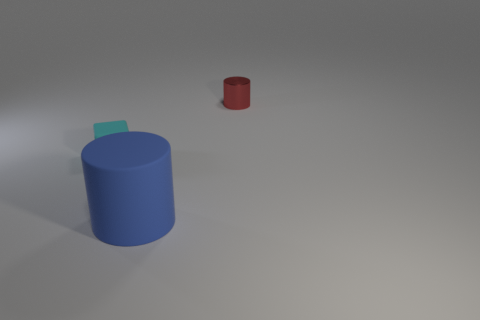Add 3 large blue matte things. How many objects exist? 6 Subtract 1 cylinders. How many cylinders are left? 1 Subtract all tiny purple rubber cylinders. Subtract all cyan blocks. How many objects are left? 2 Add 1 tiny cyan matte things. How many tiny cyan matte things are left? 2 Add 1 small purple cylinders. How many small purple cylinders exist? 1 Subtract 0 red balls. How many objects are left? 3 Subtract all cylinders. How many objects are left? 1 Subtract all brown cubes. Subtract all brown cylinders. How many cubes are left? 1 Subtract all purple blocks. How many brown cylinders are left? 0 